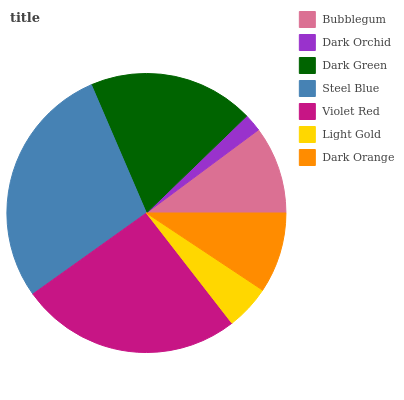Is Dark Orchid the minimum?
Answer yes or no. Yes. Is Steel Blue the maximum?
Answer yes or no. Yes. Is Dark Green the minimum?
Answer yes or no. No. Is Dark Green the maximum?
Answer yes or no. No. Is Dark Green greater than Dark Orchid?
Answer yes or no. Yes. Is Dark Orchid less than Dark Green?
Answer yes or no. Yes. Is Dark Orchid greater than Dark Green?
Answer yes or no. No. Is Dark Green less than Dark Orchid?
Answer yes or no. No. Is Bubblegum the high median?
Answer yes or no. Yes. Is Bubblegum the low median?
Answer yes or no. Yes. Is Dark Orange the high median?
Answer yes or no. No. Is Light Gold the low median?
Answer yes or no. No. 